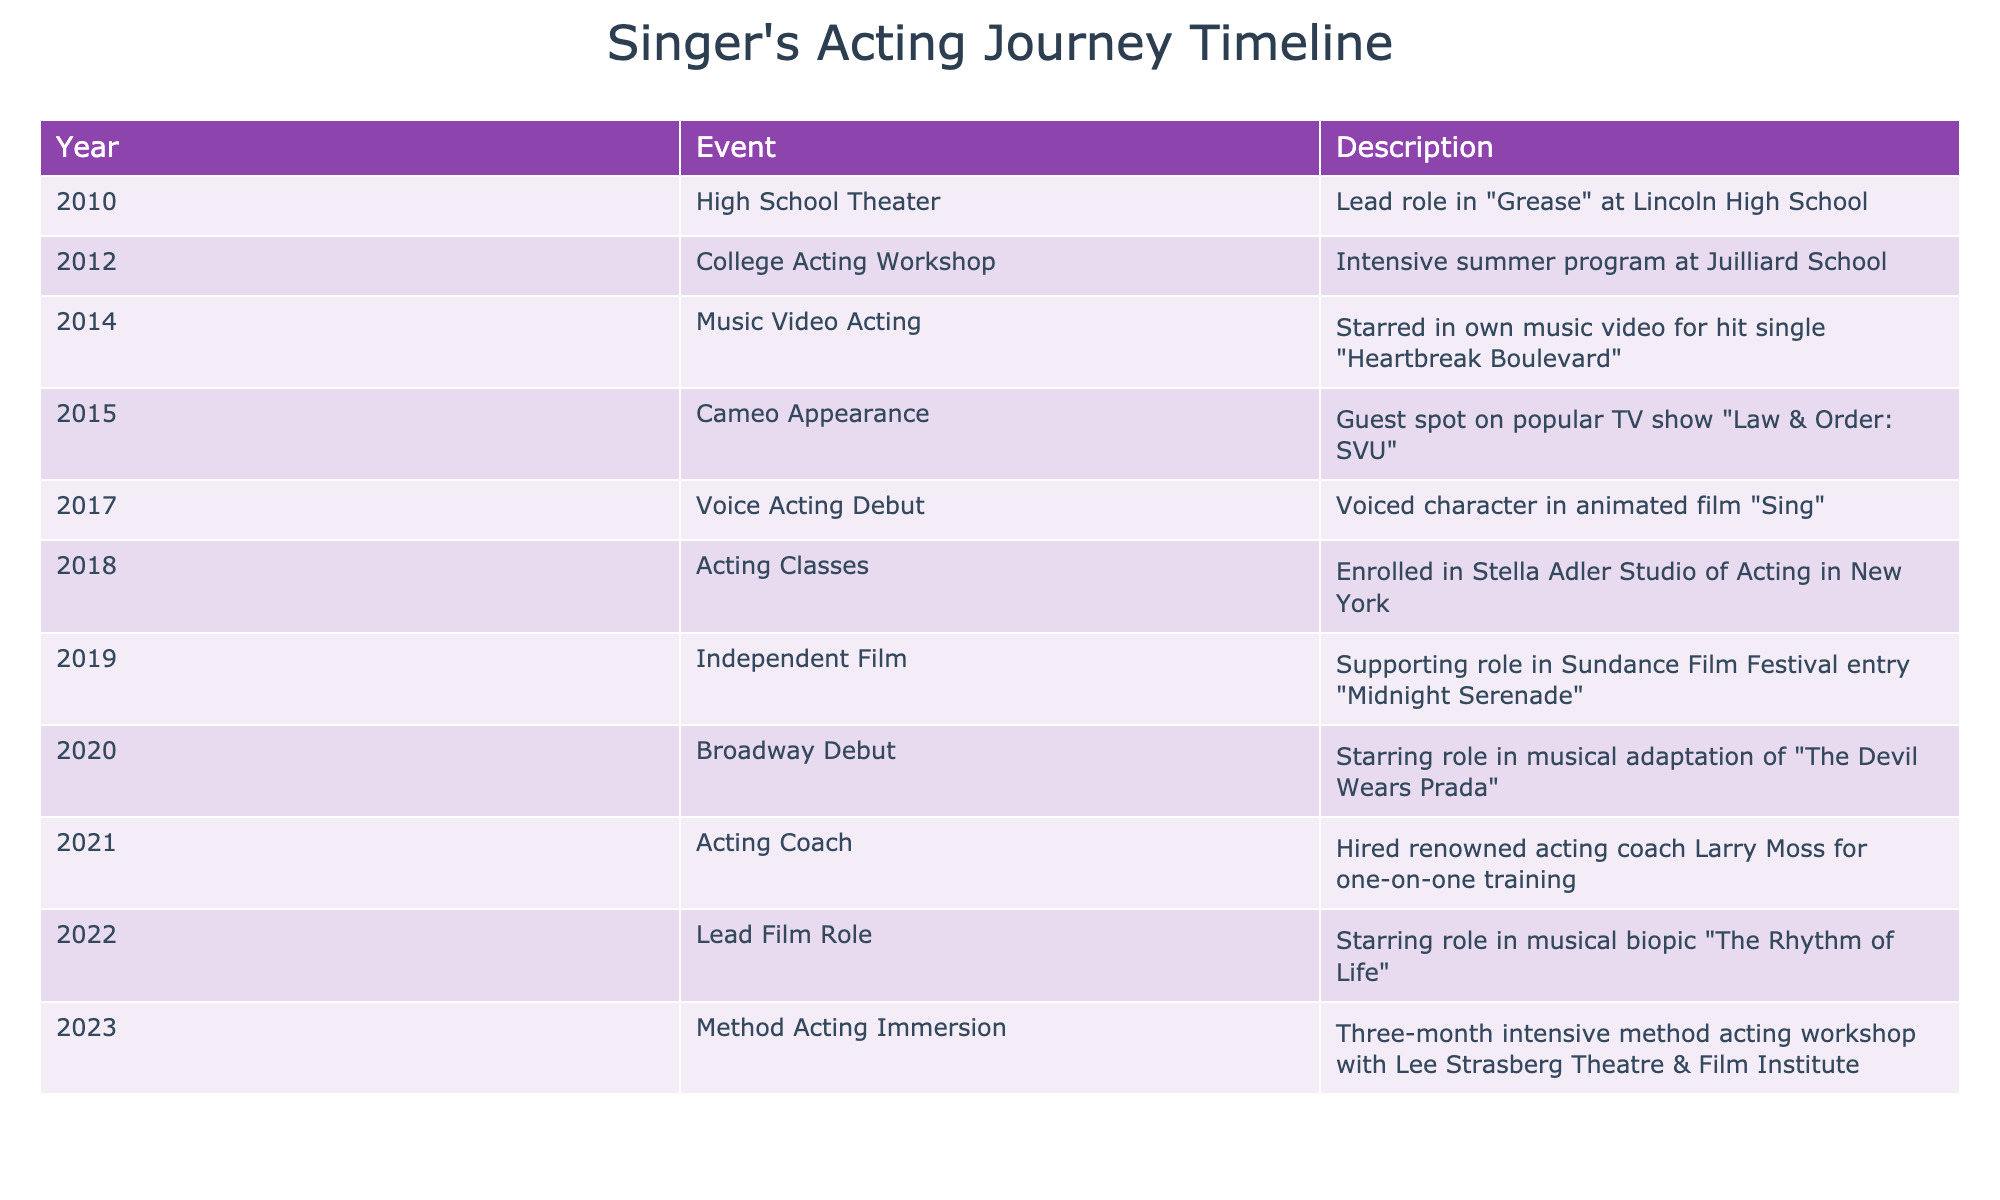What year did the singer make their Broadway debut? The table indicates that the Broadway debut occurred in the year 2020.
Answer: 2020 What events occurred in 2019? In 2019, the singer participated in an independent film where they had a supporting role in "Midnight Serenade."
Answer: Independent Film How many years passed between the singer's high school theater involvement and their lead film role? The singer was involved in high school theater in 2010 and took a lead film role in 2022, which is a difference of 12 years (2022 - 2010 = 12).
Answer: 12 years Did the singer receive any formal acting training, and if so, in what year? Yes, the singer enrolled in acting classes at the Stella Adler Studio of Acting in 2018, indicating formal training.
Answer: Yes, 2018 What was the progression of the singer's acting experiences from 2010 to 2020? The timeline shows a progression from high school theater in 2010 to college acting workshops in 2012, then music video acting in 2014, cameos on TV in 2015, voice acting in 2017, acting classes in 2018, and finally making a Broadway debut in 2020. This indicates a steady advancement in acting experiences over 10 years.
Answer: Steady advancement How many distinct types of acting experiences are listed in the timeline? The timeline includes high school theater, college acting workshop, music video acting, cameo appearances, voice acting, acting classes, film roles, and Broadway roles, totaling 8 distinct types of acting experiences.
Answer: 8 types In which year did the singer first appear in a voice acting role? The table notes that the singer made their voice acting debut in 2017.
Answer: 2017 How many years did the singer receive formal training before their lead film role in 2022? The singer trained at the Stella Adler Studio in 2018, and it is noted that they hired an acting coach in 2021. Therefore, from 2018 to 2022, they received 4 years of training prior to their lead role.
Answer: 4 years What can be inferred about the singer's development in acting from 2010 to 2023? The timeline reflects significant growth, with initial roles in high school theater, followed by structured training and diverse roles ranging from stage to screen, culminating in method acting training by 2023. This shows a clear trajectory of increasing involvement and skill in acting.
Answer: Significant growth 